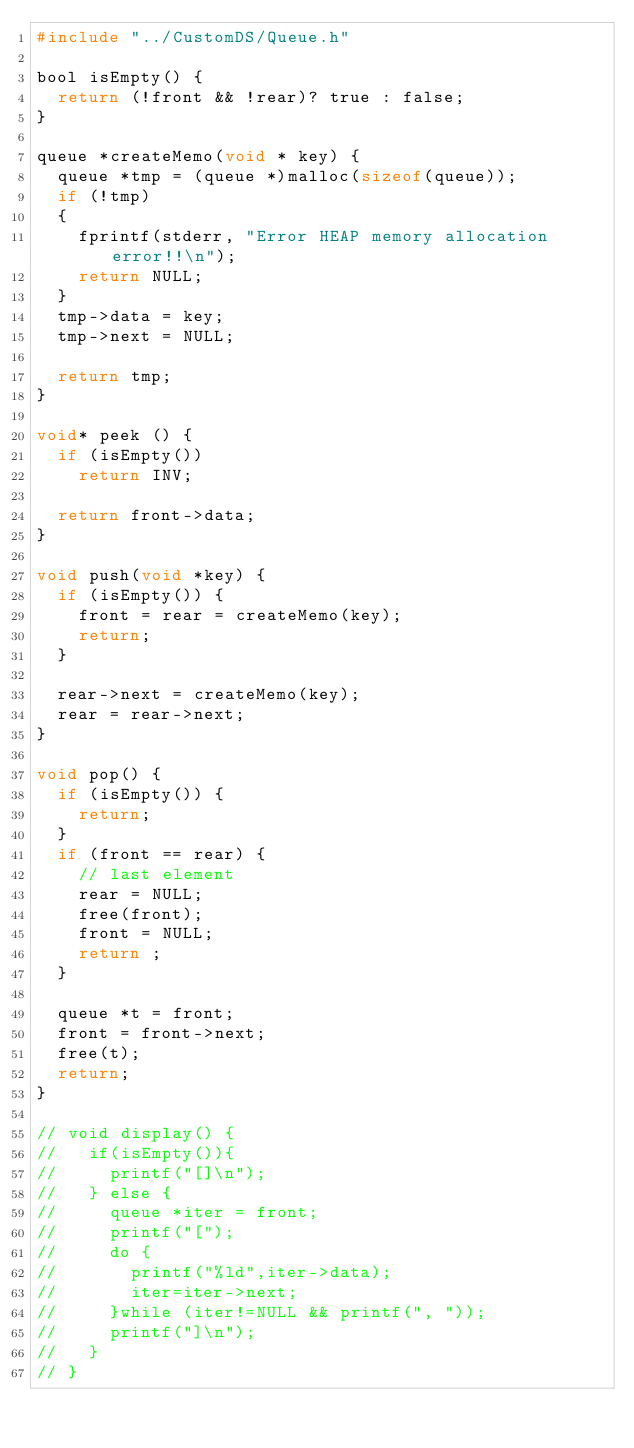Convert code to text. <code><loc_0><loc_0><loc_500><loc_500><_C_>#include "../CustomDS/Queue.h"

bool isEmpty() {
  return (!front && !rear)? true : false;
}

queue *createMemo(void * key) {
  queue *tmp = (queue *)malloc(sizeof(queue));
  if (!tmp)
  {
    fprintf(stderr, "Error HEAP memory allocation error!!\n");
    return NULL;
  }
  tmp->data = key;
  tmp->next = NULL;
  
  return tmp;
}

void* peek () {
  if (isEmpty())
    return INV;

  return front->data;
}

void push(void *key) {
  if (isEmpty()) {
    front = rear = createMemo(key);
    return;
  }

  rear->next = createMemo(key);
  rear = rear->next;
}

void pop() {
  if (isEmpty()) {
    return;
  }
  if (front == rear) {
    // last element
    rear = NULL;
    free(front);
    front = NULL;
    return ;
  }

  queue *t = front;
  front = front->next;
  free(t);
  return;
}

// void display() {
//   if(isEmpty()){
//     printf("[]\n");
//   } else {
//     queue *iter = front;
//     printf("[");
//     do {
//       printf("%ld",iter->data);
//       iter=iter->next;
//     }while (iter!=NULL && printf(", "));
//     printf("]\n");
//   }
// }</code> 